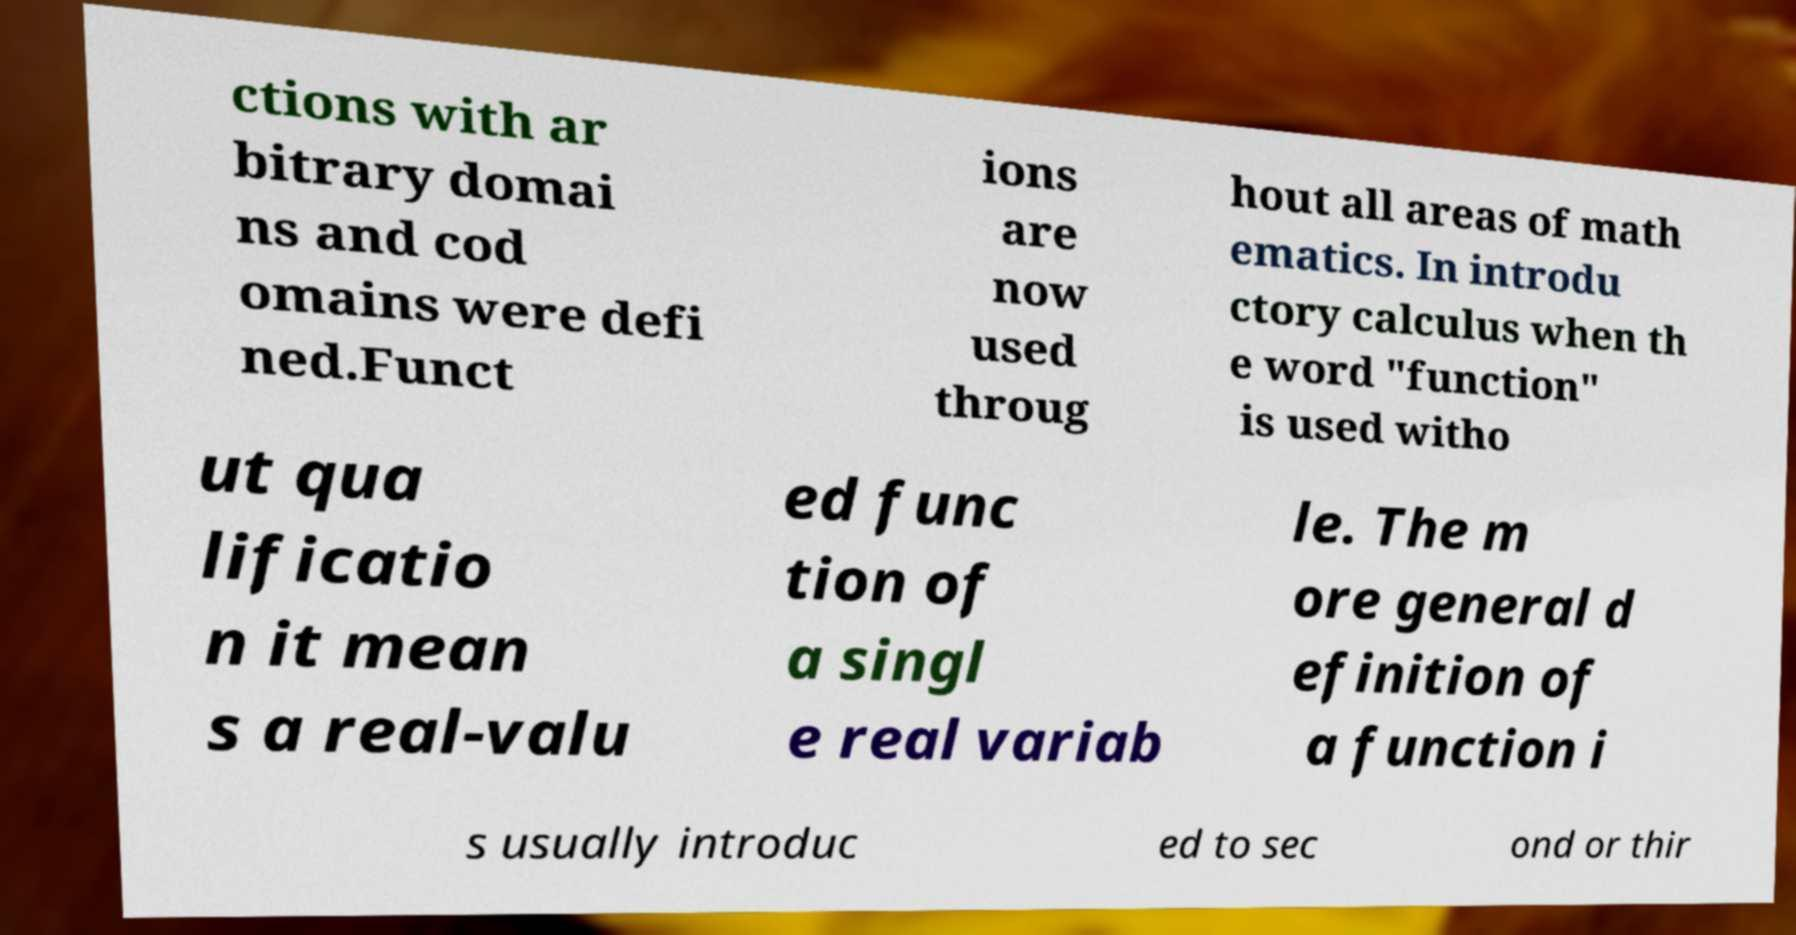I need the written content from this picture converted into text. Can you do that? ctions with ar bitrary domai ns and cod omains were defi ned.Funct ions are now used throug hout all areas of math ematics. In introdu ctory calculus when th e word "function" is used witho ut qua lificatio n it mean s a real-valu ed func tion of a singl e real variab le. The m ore general d efinition of a function i s usually introduc ed to sec ond or thir 